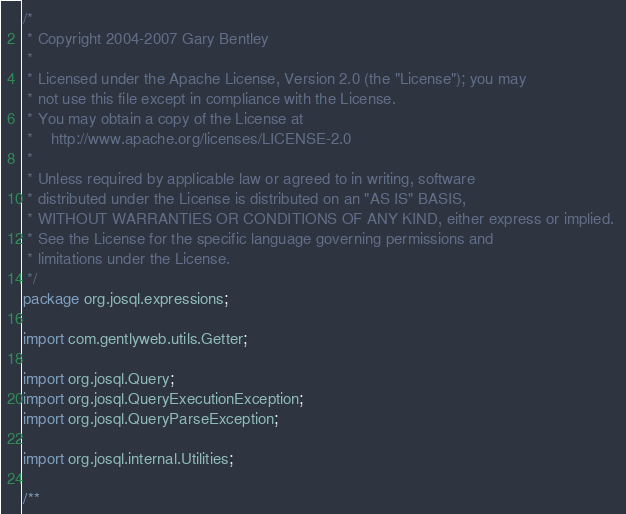<code> <loc_0><loc_0><loc_500><loc_500><_Java_>/*
 * Copyright 2004-2007 Gary Bentley 
 * 
 * Licensed under the Apache License, Version 2.0 (the "License"); you may 
 * not use this file except in compliance with the License. 
 * You may obtain a copy of the License at 
 *    http://www.apache.org/licenses/LICENSE-2.0 
 *
 * Unless required by applicable law or agreed to in writing, software 
 * distributed under the License is distributed on an "AS IS" BASIS, 
 * WITHOUT WARRANTIES OR CONDITIONS OF ANY KIND, either express or implied. 
 * See the License for the specific language governing permissions and 
 * limitations under the License.
 */
package org.josql.expressions;

import com.gentlyweb.utils.Getter;

import org.josql.Query;
import org.josql.QueryExecutionException;
import org.josql.QueryParseException;

import org.josql.internal.Utilities;

/**</code> 